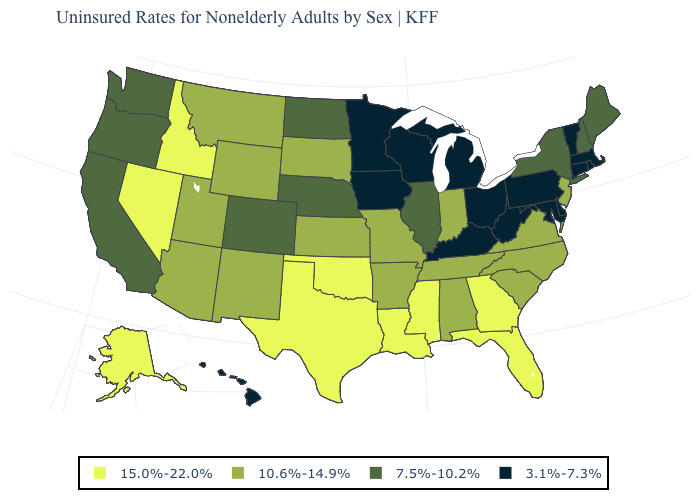What is the value of New York?
Keep it brief. 7.5%-10.2%. What is the value of Texas?
Quick response, please. 15.0%-22.0%. Among the states that border Delaware , which have the lowest value?
Keep it brief. Maryland, Pennsylvania. What is the lowest value in states that border Wyoming?
Be succinct. 7.5%-10.2%. What is the value of New Hampshire?
Quick response, please. 7.5%-10.2%. How many symbols are there in the legend?
Quick response, please. 4. Name the states that have a value in the range 15.0%-22.0%?
Write a very short answer. Alaska, Florida, Georgia, Idaho, Louisiana, Mississippi, Nevada, Oklahoma, Texas. Which states have the lowest value in the USA?
Answer briefly. Connecticut, Delaware, Hawaii, Iowa, Kentucky, Maryland, Massachusetts, Michigan, Minnesota, Ohio, Pennsylvania, Rhode Island, Vermont, West Virginia, Wisconsin. What is the highest value in the USA?
Concise answer only. 15.0%-22.0%. What is the highest value in the MidWest ?
Short answer required. 10.6%-14.9%. Name the states that have a value in the range 10.6%-14.9%?
Give a very brief answer. Alabama, Arizona, Arkansas, Indiana, Kansas, Missouri, Montana, New Jersey, New Mexico, North Carolina, South Carolina, South Dakota, Tennessee, Utah, Virginia, Wyoming. Which states have the lowest value in the Northeast?
Short answer required. Connecticut, Massachusetts, Pennsylvania, Rhode Island, Vermont. Among the states that border New Mexico , which have the lowest value?
Give a very brief answer. Colorado. What is the lowest value in the USA?
Write a very short answer. 3.1%-7.3%. 